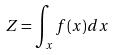Convert formula to latex. <formula><loc_0><loc_0><loc_500><loc_500>Z = \int _ { x } f ( x ) d x</formula> 